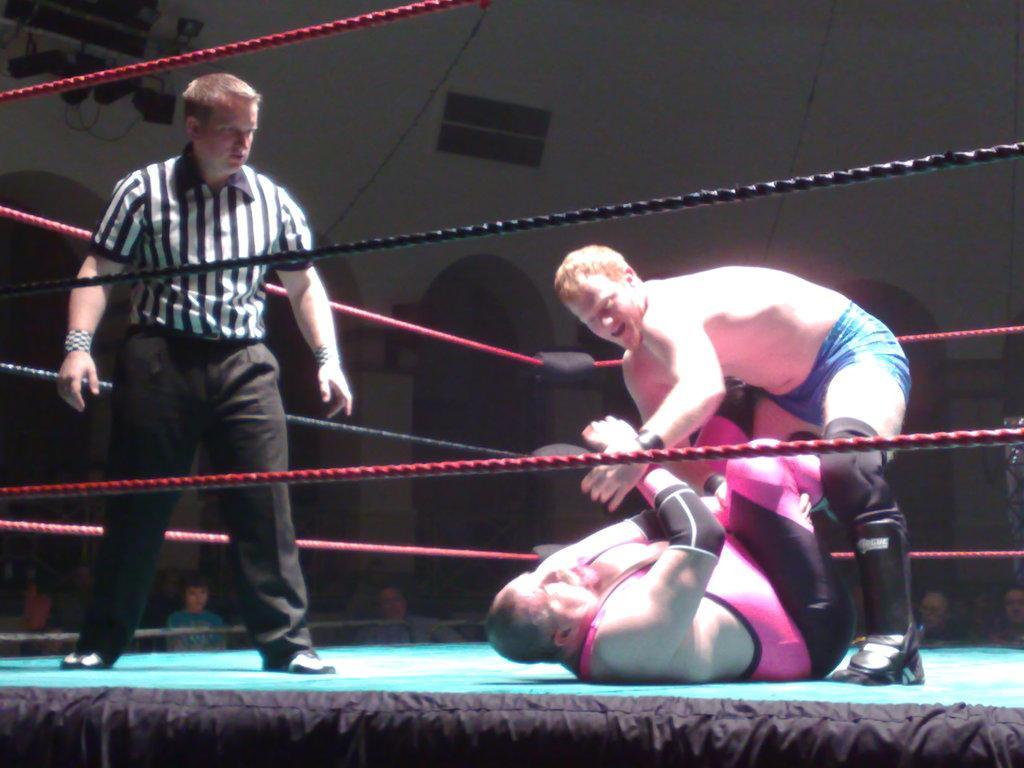In one or two sentences, can you explain what this image depicts? In this image we can see some people standing on the stage. One person is lying on the stage. In the foreground we can see some ropes. In the background, we can see some people, a group of lights and some pillars. 